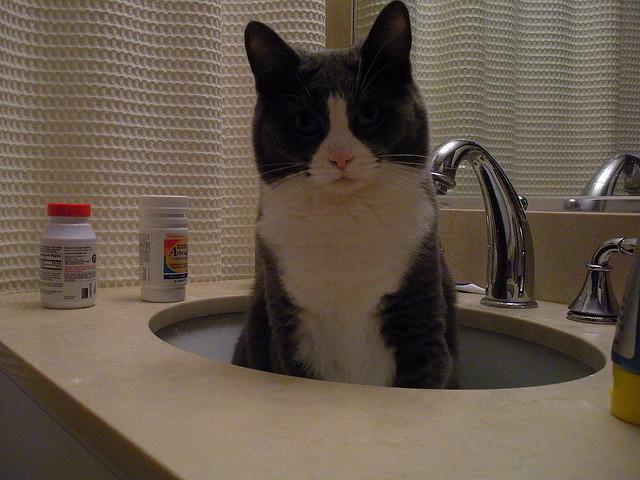How many bottles are there?
Give a very brief answer. 2. 